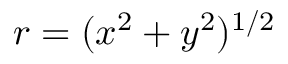Convert formula to latex. <formula><loc_0><loc_0><loc_500><loc_500>r = ( x ^ { 2 } + y ^ { 2 } ) ^ { 1 / 2 }</formula> 